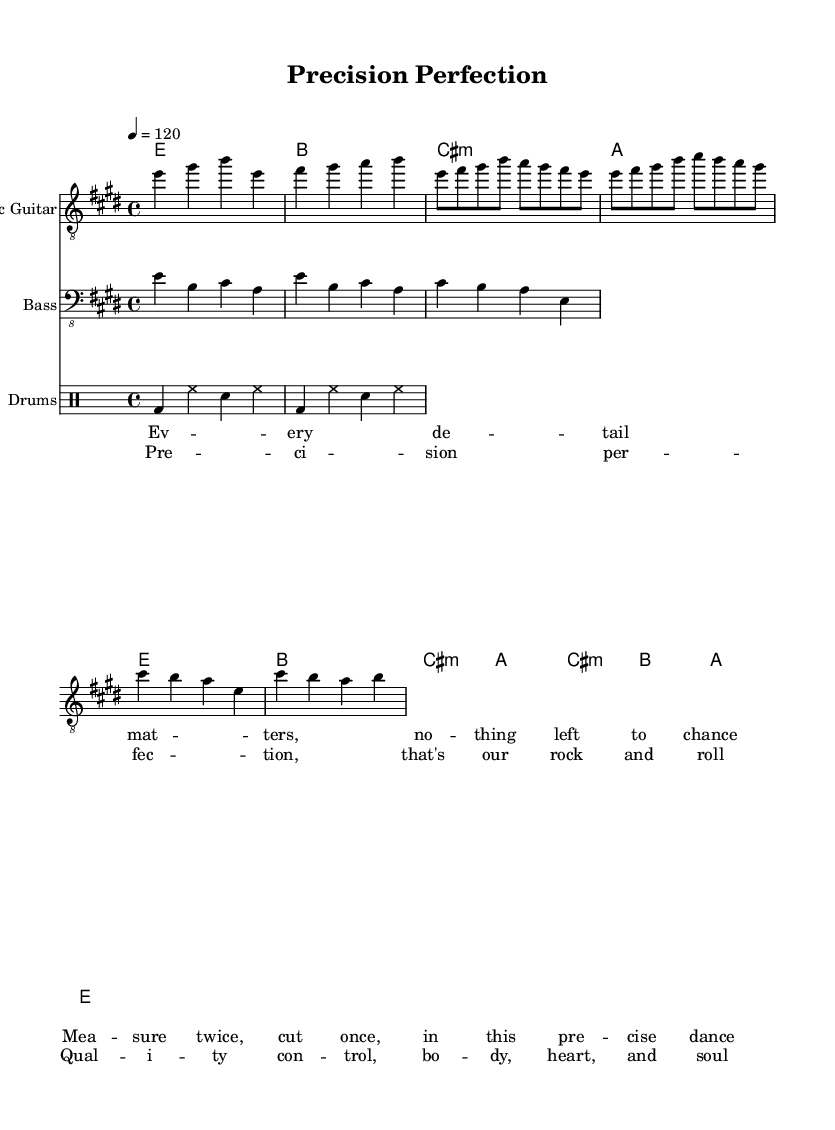What is the key signature of this music? The key signature is indicated by the two sharps seen at the beginning of the sheet music. This corresponds to E major.
Answer: E major What is the time signature of this music? The time signature is represented by the '4/4' seen at the beginning of the score, indicating four beats per measure.
Answer: 4/4 What is the tempo marking for this piece? The tempo is indicated by the notation '4 = 120' at the beginning. This means there are 120 quarter note beats per minute.
Answer: 120 How many measures are in the chorus section of the song? Counting the measures in the chorus section (cis, b, a, e) shows there are four measures, as also is seen in the formatted chorus part.
Answer: 4 Which instruments are included in this score? The score includes three instruments: Electric Guitar, Bass, and Drums, as indicated by the instrument names at the beginning of their respective staves.
Answer: Electric Guitar, Bass, Drums What lyric theme is suggested in the verse? The lyrics in the verse mention precision and a meticulous approach to detail, reflecting the theme of carefulness and quality control in the creative process.
Answer: Precision What type of rock is represented by the song? The elements, including the chord structure and lyrical focus on detail, suggest that this song aligns with classic rock, characterized by strong melodies and rhythmic guitar work.
Answer: Classic rock 